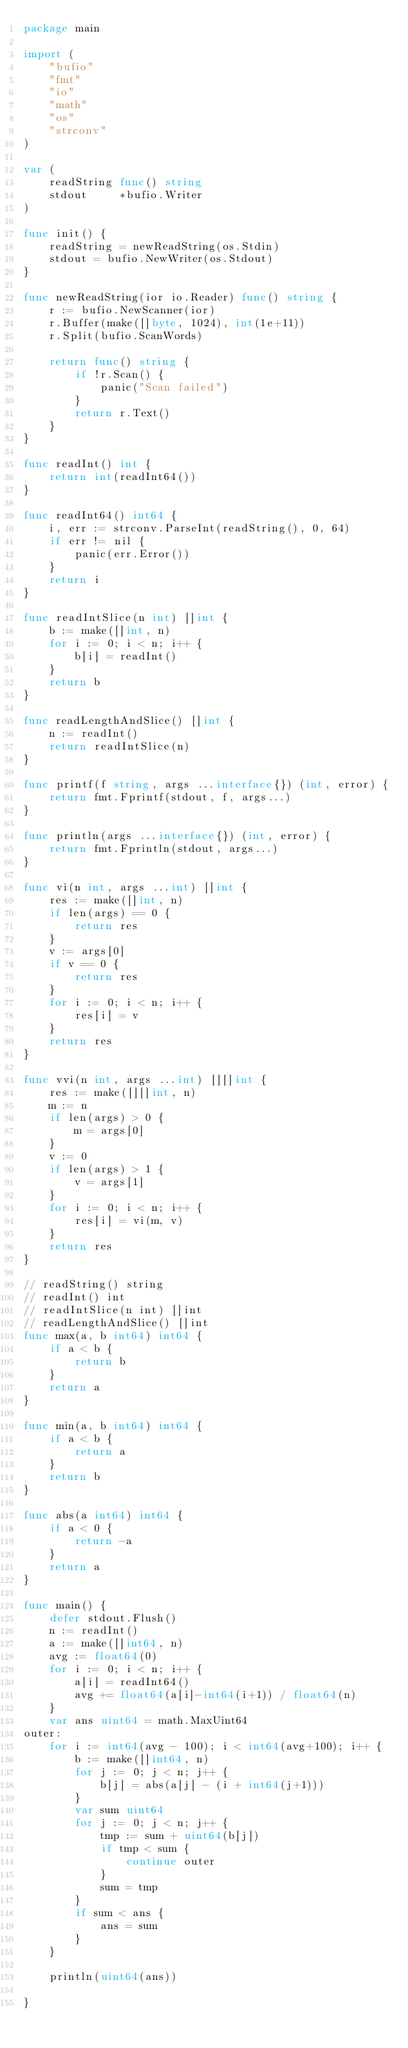Convert code to text. <code><loc_0><loc_0><loc_500><loc_500><_Go_>package main

import (
	"bufio"
	"fmt"
	"io"
	"math"
	"os"
	"strconv"
)

var (
	readString func() string
	stdout     *bufio.Writer
)

func init() {
	readString = newReadString(os.Stdin)
	stdout = bufio.NewWriter(os.Stdout)
}

func newReadString(ior io.Reader) func() string {
	r := bufio.NewScanner(ior)
	r.Buffer(make([]byte, 1024), int(1e+11))
	r.Split(bufio.ScanWords)

	return func() string {
		if !r.Scan() {
			panic("Scan failed")
		}
		return r.Text()
	}
}

func readInt() int {
	return int(readInt64())
}

func readInt64() int64 {
	i, err := strconv.ParseInt(readString(), 0, 64)
	if err != nil {
		panic(err.Error())
	}
	return i
}

func readIntSlice(n int) []int {
	b := make([]int, n)
	for i := 0; i < n; i++ {
		b[i] = readInt()
	}
	return b
}

func readLengthAndSlice() []int {
	n := readInt()
	return readIntSlice(n)
}

func printf(f string, args ...interface{}) (int, error) {
	return fmt.Fprintf(stdout, f, args...)
}

func println(args ...interface{}) (int, error) {
	return fmt.Fprintln(stdout, args...)
}

func vi(n int, args ...int) []int {
	res := make([]int, n)
	if len(args) == 0 {
		return res
	}
	v := args[0]
	if v == 0 {
		return res
	}
	for i := 0; i < n; i++ {
		res[i] = v
	}
	return res
}

func vvi(n int, args ...int) [][]int {
	res := make([][]int, n)
	m := n
	if len(args) > 0 {
		m = args[0]
	}
	v := 0
	if len(args) > 1 {
		v = args[1]
	}
	for i := 0; i < n; i++ {
		res[i] = vi(m, v)
	}
	return res
}

// readString() string
// readInt() int
// readIntSlice(n int) []int
// readLengthAndSlice() []int
func max(a, b int64) int64 {
	if a < b {
		return b
	}
	return a
}

func min(a, b int64) int64 {
	if a < b {
		return a
	}
	return b
}

func abs(a int64) int64 {
	if a < 0 {
		return -a
	}
	return a
}

func main() {
	defer stdout.Flush()
	n := readInt()
	a := make([]int64, n)
	avg := float64(0)
	for i := 0; i < n; i++ {
		a[i] = readInt64()
		avg += float64(a[i]-int64(i+1)) / float64(n)
	}
	var ans uint64 = math.MaxUint64
outer:
	for i := int64(avg - 100); i < int64(avg+100); i++ {
		b := make([]int64, n)
		for j := 0; j < n; j++ {
			b[j] = abs(a[j] - (i + int64(j+1)))
		}
		var sum uint64
		for j := 0; j < n; j++ {
			tmp := sum + uint64(b[j])
			if tmp < sum {
				continue outer
			}
			sum = tmp
		}
		if sum < ans {
			ans = sum
		}
	}

	println(uint64(ans))

}
</code> 